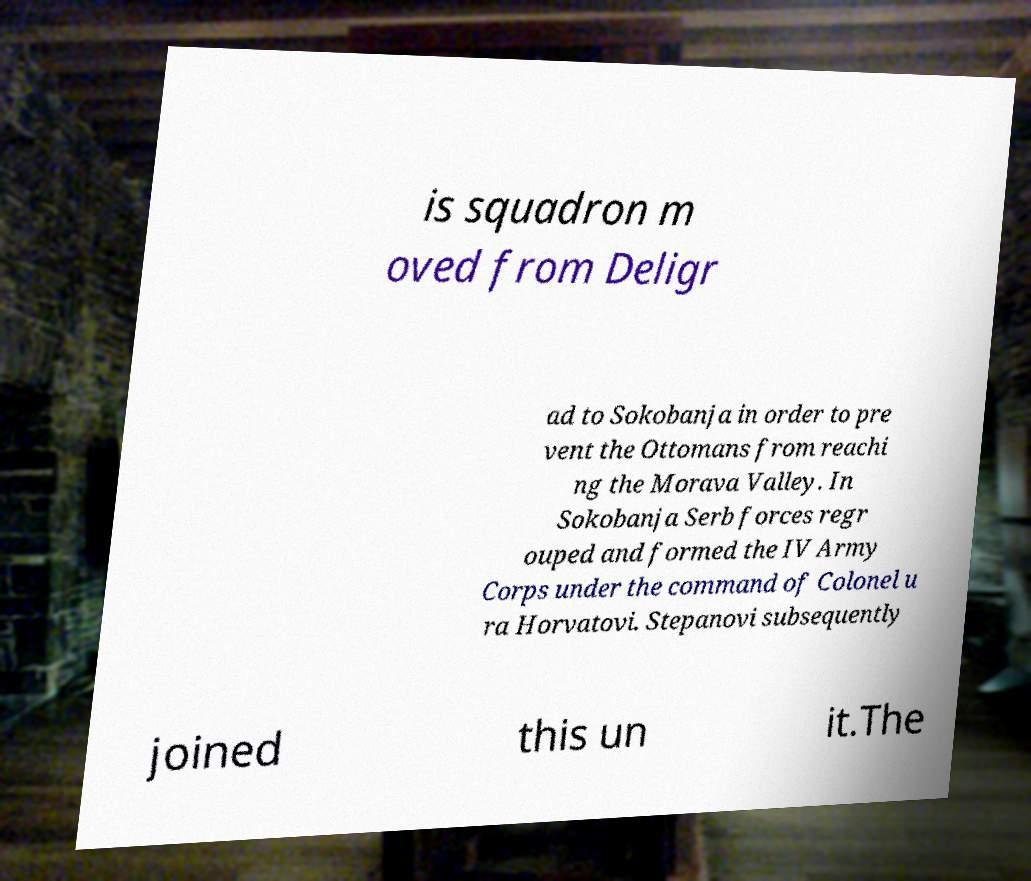Please identify and transcribe the text found in this image. is squadron m oved from Deligr ad to Sokobanja in order to pre vent the Ottomans from reachi ng the Morava Valley. In Sokobanja Serb forces regr ouped and formed the IV Army Corps under the command of Colonel u ra Horvatovi. Stepanovi subsequently joined this un it.The 